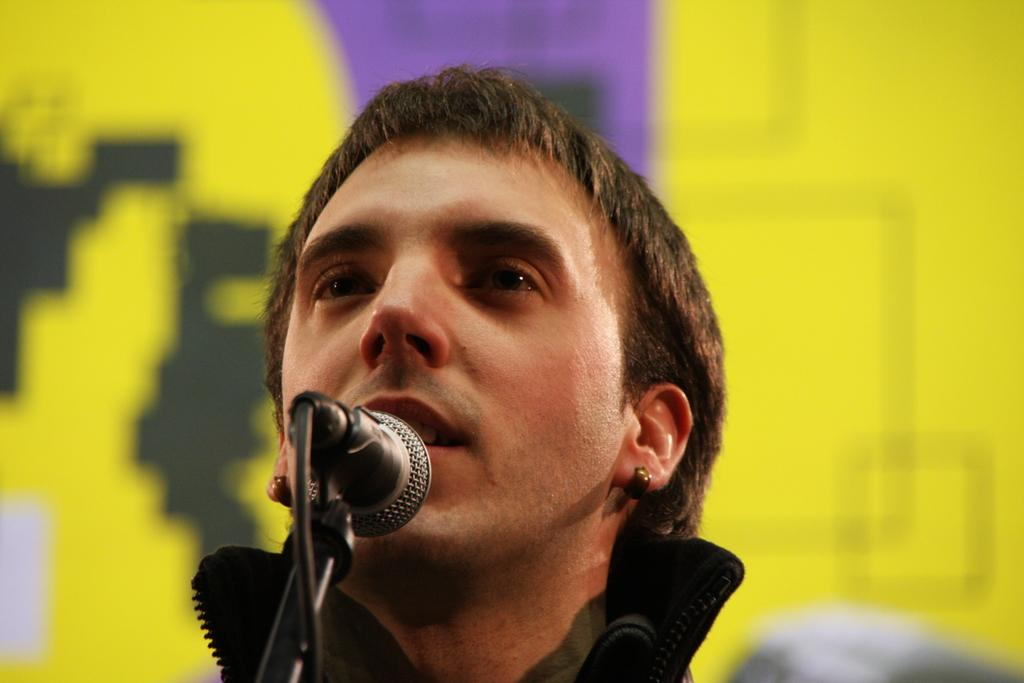Who is present in the image? There is a man in the image. What is the man wearing? The man is wearing clothes and earrings. What object can be seen in the man's hand? There is a microphone in the image. What is connected to the microphone? There is a cable wire in the image. Can you describe the background of the image? The background of the image is blurred. What type of stone is the man holding in the image? There is no stone present in the image; the man is holding a microphone. What is the man's belief system, as depicted in the image? The image does not provide any information about the man's belief system. 